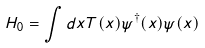Convert formula to latex. <formula><loc_0><loc_0><loc_500><loc_500>H _ { 0 } = \int d x T ( x ) \psi ^ { \dag } ( x ) \psi ( x )</formula> 